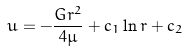<formula> <loc_0><loc_0><loc_500><loc_500>u = - { \frac { G r ^ { 2 } } { 4 \mu } } + c _ { 1 } \ln r + c _ { 2 }</formula> 